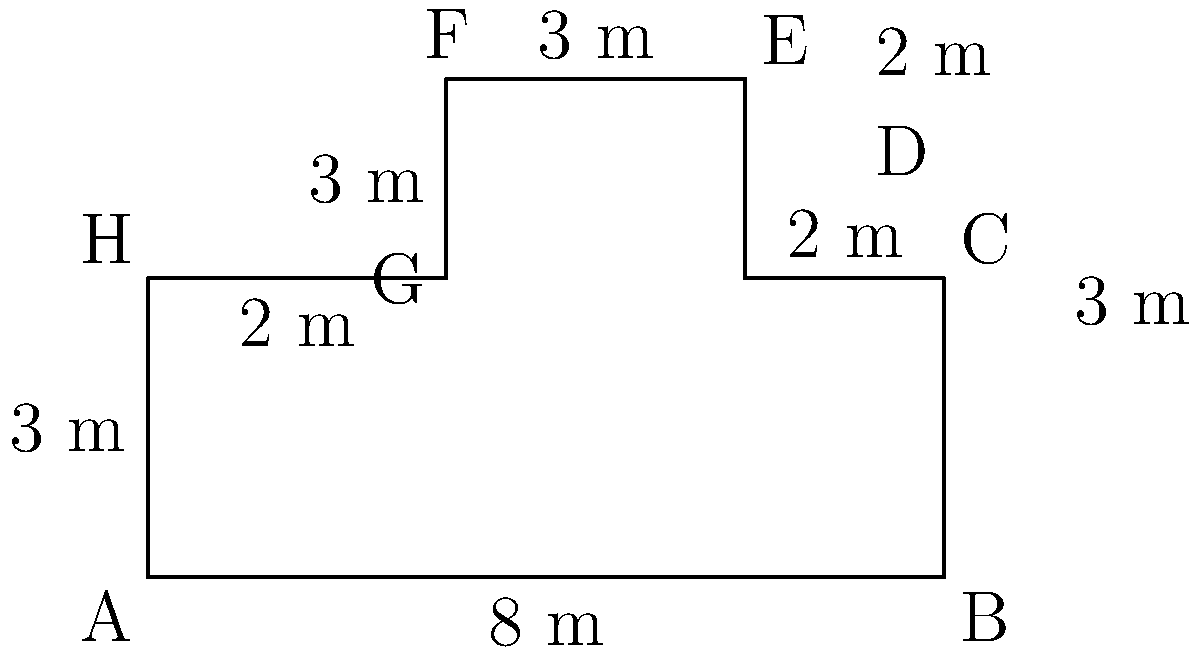As a health-conscious student at BCTC, you're concerned about maintaining proper social distancing while walking around campus buildings. The floor plan of a new health sciences building is shown above. Calculate the perimeter of this building to determine the total distance you'd need to walk to go around it once, ensuring you stay as close to the walls as possible for maximum safety. To calculate the perimeter of this irregular polygon, we need to sum up the lengths of all sides:

1. Side AB: 8 m
2. Side BC: 3 m
3. Side CD: 2 m
4. Side DE: 2 m
5. Side EF: 3 m
6. Side FG: 3 m
7. Side GH: 2 m
8. Side HA: 3 m

Now, let's add all these lengths:

$$ \text{Perimeter} = 8 + 3 + 2 + 2 + 3 + 3 + 2 + 3 = 26 \text{ m} $$

Therefore, the total distance you'd need to walk to go around the building once, staying close to the walls, is 26 meters.
Answer: 26 m 